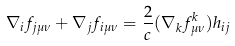<formula> <loc_0><loc_0><loc_500><loc_500>\nabla _ { i } f _ { j \mu \nu } + \nabla _ { j } f _ { i \mu \nu } = \frac { 2 } { c } ( \nabla _ { k } f ^ { k } _ { \mu \nu } ) h _ { i j }</formula> 